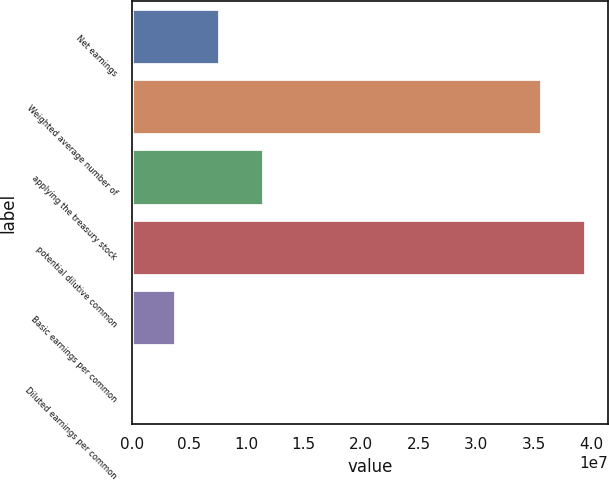<chart> <loc_0><loc_0><loc_500><loc_500><bar_chart><fcel>Net earnings<fcel>Weighted average number of<fcel>applying the treasury stock<fcel>potential dilutive common<fcel>Basic earnings per common<fcel>Diluted earnings per common<nl><fcel>7.68443e+06<fcel>3.57044e+07<fcel>1.15266e+07<fcel>3.95466e+07<fcel>3.84222e+06<fcel>0.87<nl></chart> 